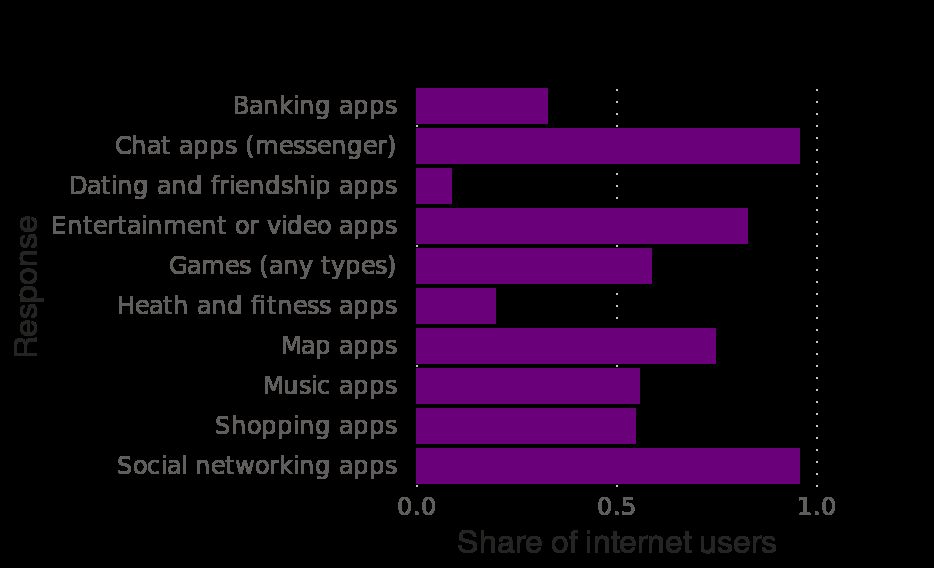<image>
Offer a thorough analysis of the image. Communication and entertainment apps have highest proportion of users in Q3. Health and fitness and dating apps have the lowest proportion of users. You can assume from this that users prefer to use apps for communication and entertainment purposes. What types of apps have the highest proportion of users in Q3? Communication and entertainment apps have the highest proportion of users in Q3. What does the bar diagram depict?  The bar diagram depicts the share of internet users using mobile apps in Indonesia categorized by different categories. 